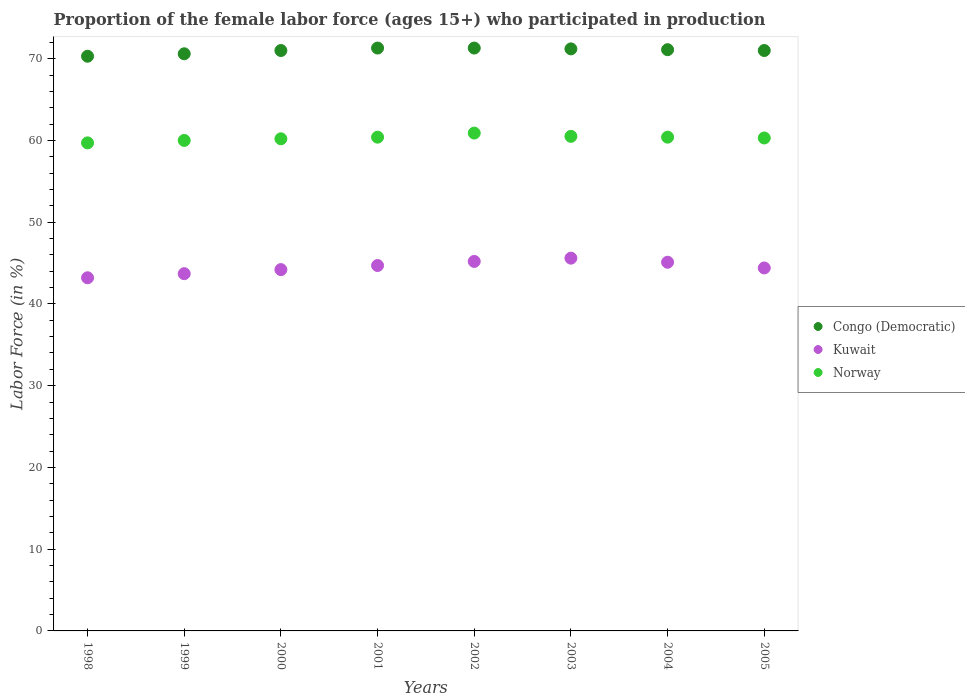Is the number of dotlines equal to the number of legend labels?
Offer a very short reply. Yes. What is the proportion of the female labor force who participated in production in Norway in 1998?
Ensure brevity in your answer.  59.7. Across all years, what is the maximum proportion of the female labor force who participated in production in Congo (Democratic)?
Offer a very short reply. 71.3. Across all years, what is the minimum proportion of the female labor force who participated in production in Norway?
Give a very brief answer. 59.7. In which year was the proportion of the female labor force who participated in production in Norway maximum?
Give a very brief answer. 2002. What is the total proportion of the female labor force who participated in production in Kuwait in the graph?
Your response must be concise. 356.1. What is the difference between the proportion of the female labor force who participated in production in Congo (Democratic) in 2001 and that in 2003?
Provide a short and direct response. 0.1. What is the difference between the proportion of the female labor force who participated in production in Norway in 1999 and the proportion of the female labor force who participated in production in Kuwait in 2000?
Offer a terse response. 15.8. What is the average proportion of the female labor force who participated in production in Congo (Democratic) per year?
Your answer should be very brief. 70.98. In the year 2001, what is the difference between the proportion of the female labor force who participated in production in Congo (Democratic) and proportion of the female labor force who participated in production in Kuwait?
Make the answer very short. 26.6. In how many years, is the proportion of the female labor force who participated in production in Congo (Democratic) greater than 44 %?
Offer a terse response. 8. What is the ratio of the proportion of the female labor force who participated in production in Congo (Democratic) in 2000 to that in 2001?
Your answer should be very brief. 1. What is the difference between the highest and the lowest proportion of the female labor force who participated in production in Kuwait?
Provide a short and direct response. 2.4. In how many years, is the proportion of the female labor force who participated in production in Norway greater than the average proportion of the female labor force who participated in production in Norway taken over all years?
Offer a terse response. 4. Is it the case that in every year, the sum of the proportion of the female labor force who participated in production in Congo (Democratic) and proportion of the female labor force who participated in production in Norway  is greater than the proportion of the female labor force who participated in production in Kuwait?
Offer a very short reply. Yes. Is the proportion of the female labor force who participated in production in Congo (Democratic) strictly greater than the proportion of the female labor force who participated in production in Kuwait over the years?
Offer a terse response. Yes. Is the proportion of the female labor force who participated in production in Kuwait strictly less than the proportion of the female labor force who participated in production in Norway over the years?
Your answer should be compact. Yes. How many dotlines are there?
Make the answer very short. 3. How many years are there in the graph?
Keep it short and to the point. 8. What is the difference between two consecutive major ticks on the Y-axis?
Your answer should be very brief. 10. Does the graph contain grids?
Ensure brevity in your answer.  No. Where does the legend appear in the graph?
Offer a very short reply. Center right. How many legend labels are there?
Provide a succinct answer. 3. How are the legend labels stacked?
Your answer should be compact. Vertical. What is the title of the graph?
Provide a succinct answer. Proportion of the female labor force (ages 15+) who participated in production. What is the label or title of the Y-axis?
Your response must be concise. Labor Force (in %). What is the Labor Force (in %) of Congo (Democratic) in 1998?
Make the answer very short. 70.3. What is the Labor Force (in %) in Kuwait in 1998?
Make the answer very short. 43.2. What is the Labor Force (in %) of Norway in 1998?
Your answer should be very brief. 59.7. What is the Labor Force (in %) in Congo (Democratic) in 1999?
Offer a terse response. 70.6. What is the Labor Force (in %) in Kuwait in 1999?
Ensure brevity in your answer.  43.7. What is the Labor Force (in %) in Norway in 1999?
Provide a short and direct response. 60. What is the Labor Force (in %) in Congo (Democratic) in 2000?
Your answer should be very brief. 71. What is the Labor Force (in %) of Kuwait in 2000?
Offer a very short reply. 44.2. What is the Labor Force (in %) of Norway in 2000?
Provide a short and direct response. 60.2. What is the Labor Force (in %) in Congo (Democratic) in 2001?
Keep it short and to the point. 71.3. What is the Labor Force (in %) in Kuwait in 2001?
Your response must be concise. 44.7. What is the Labor Force (in %) of Norway in 2001?
Ensure brevity in your answer.  60.4. What is the Labor Force (in %) in Congo (Democratic) in 2002?
Offer a very short reply. 71.3. What is the Labor Force (in %) of Kuwait in 2002?
Give a very brief answer. 45.2. What is the Labor Force (in %) of Norway in 2002?
Make the answer very short. 60.9. What is the Labor Force (in %) in Congo (Democratic) in 2003?
Ensure brevity in your answer.  71.2. What is the Labor Force (in %) in Kuwait in 2003?
Your response must be concise. 45.6. What is the Labor Force (in %) of Norway in 2003?
Ensure brevity in your answer.  60.5. What is the Labor Force (in %) of Congo (Democratic) in 2004?
Provide a succinct answer. 71.1. What is the Labor Force (in %) in Kuwait in 2004?
Your response must be concise. 45.1. What is the Labor Force (in %) of Norway in 2004?
Keep it short and to the point. 60.4. What is the Labor Force (in %) in Congo (Democratic) in 2005?
Provide a succinct answer. 71. What is the Labor Force (in %) in Kuwait in 2005?
Keep it short and to the point. 44.4. What is the Labor Force (in %) in Norway in 2005?
Ensure brevity in your answer.  60.3. Across all years, what is the maximum Labor Force (in %) of Congo (Democratic)?
Your answer should be very brief. 71.3. Across all years, what is the maximum Labor Force (in %) of Kuwait?
Offer a terse response. 45.6. Across all years, what is the maximum Labor Force (in %) of Norway?
Give a very brief answer. 60.9. Across all years, what is the minimum Labor Force (in %) of Congo (Democratic)?
Your response must be concise. 70.3. Across all years, what is the minimum Labor Force (in %) in Kuwait?
Provide a succinct answer. 43.2. Across all years, what is the minimum Labor Force (in %) in Norway?
Give a very brief answer. 59.7. What is the total Labor Force (in %) of Congo (Democratic) in the graph?
Ensure brevity in your answer.  567.8. What is the total Labor Force (in %) in Kuwait in the graph?
Keep it short and to the point. 356.1. What is the total Labor Force (in %) of Norway in the graph?
Provide a short and direct response. 482.4. What is the difference between the Labor Force (in %) of Congo (Democratic) in 1998 and that in 1999?
Provide a short and direct response. -0.3. What is the difference between the Labor Force (in %) of Kuwait in 1998 and that in 1999?
Your answer should be compact. -0.5. What is the difference between the Labor Force (in %) of Congo (Democratic) in 1998 and that in 2000?
Provide a succinct answer. -0.7. What is the difference between the Labor Force (in %) in Kuwait in 1998 and that in 2001?
Keep it short and to the point. -1.5. What is the difference between the Labor Force (in %) of Norway in 1998 and that in 2001?
Your answer should be compact. -0.7. What is the difference between the Labor Force (in %) in Kuwait in 1998 and that in 2002?
Your answer should be compact. -2. What is the difference between the Labor Force (in %) of Kuwait in 1998 and that in 2003?
Your response must be concise. -2.4. What is the difference between the Labor Force (in %) of Congo (Democratic) in 1998 and that in 2004?
Provide a succinct answer. -0.8. What is the difference between the Labor Force (in %) in Kuwait in 1998 and that in 2004?
Provide a succinct answer. -1.9. What is the difference between the Labor Force (in %) in Kuwait in 1999 and that in 2000?
Make the answer very short. -0.5. What is the difference between the Labor Force (in %) in Norway in 1999 and that in 2000?
Offer a very short reply. -0.2. What is the difference between the Labor Force (in %) of Norway in 1999 and that in 2001?
Your answer should be very brief. -0.4. What is the difference between the Labor Force (in %) of Kuwait in 1999 and that in 2002?
Ensure brevity in your answer.  -1.5. What is the difference between the Labor Force (in %) in Norway in 1999 and that in 2002?
Give a very brief answer. -0.9. What is the difference between the Labor Force (in %) in Kuwait in 1999 and that in 2003?
Offer a terse response. -1.9. What is the difference between the Labor Force (in %) in Congo (Democratic) in 1999 and that in 2004?
Make the answer very short. -0.5. What is the difference between the Labor Force (in %) in Kuwait in 1999 and that in 2004?
Keep it short and to the point. -1.4. What is the difference between the Labor Force (in %) in Norway in 1999 and that in 2004?
Ensure brevity in your answer.  -0.4. What is the difference between the Labor Force (in %) in Congo (Democratic) in 1999 and that in 2005?
Your answer should be very brief. -0.4. What is the difference between the Labor Force (in %) of Kuwait in 1999 and that in 2005?
Provide a succinct answer. -0.7. What is the difference between the Labor Force (in %) of Congo (Democratic) in 2000 and that in 2001?
Your answer should be very brief. -0.3. What is the difference between the Labor Force (in %) of Kuwait in 2000 and that in 2002?
Your response must be concise. -1. What is the difference between the Labor Force (in %) in Congo (Democratic) in 2000 and that in 2004?
Your answer should be very brief. -0.1. What is the difference between the Labor Force (in %) of Kuwait in 2000 and that in 2004?
Keep it short and to the point. -0.9. What is the difference between the Labor Force (in %) of Norway in 2001 and that in 2002?
Make the answer very short. -0.5. What is the difference between the Labor Force (in %) of Congo (Democratic) in 2001 and that in 2004?
Provide a succinct answer. 0.2. What is the difference between the Labor Force (in %) in Norway in 2001 and that in 2004?
Your answer should be compact. 0. What is the difference between the Labor Force (in %) of Congo (Democratic) in 2001 and that in 2005?
Offer a very short reply. 0.3. What is the difference between the Labor Force (in %) in Kuwait in 2001 and that in 2005?
Give a very brief answer. 0.3. What is the difference between the Labor Force (in %) of Congo (Democratic) in 2002 and that in 2003?
Your answer should be compact. 0.1. What is the difference between the Labor Force (in %) in Congo (Democratic) in 2002 and that in 2004?
Offer a very short reply. 0.2. What is the difference between the Labor Force (in %) of Norway in 2002 and that in 2004?
Keep it short and to the point. 0.5. What is the difference between the Labor Force (in %) in Congo (Democratic) in 2002 and that in 2005?
Give a very brief answer. 0.3. What is the difference between the Labor Force (in %) of Congo (Democratic) in 2003 and that in 2004?
Ensure brevity in your answer.  0.1. What is the difference between the Labor Force (in %) in Norway in 2003 and that in 2004?
Your answer should be compact. 0.1. What is the difference between the Labor Force (in %) in Congo (Democratic) in 2003 and that in 2005?
Make the answer very short. 0.2. What is the difference between the Labor Force (in %) of Norway in 2003 and that in 2005?
Provide a short and direct response. 0.2. What is the difference between the Labor Force (in %) in Kuwait in 2004 and that in 2005?
Provide a short and direct response. 0.7. What is the difference between the Labor Force (in %) in Congo (Democratic) in 1998 and the Labor Force (in %) in Kuwait in 1999?
Keep it short and to the point. 26.6. What is the difference between the Labor Force (in %) of Kuwait in 1998 and the Labor Force (in %) of Norway in 1999?
Offer a very short reply. -16.8. What is the difference between the Labor Force (in %) in Congo (Democratic) in 1998 and the Labor Force (in %) in Kuwait in 2000?
Provide a short and direct response. 26.1. What is the difference between the Labor Force (in %) in Congo (Democratic) in 1998 and the Labor Force (in %) in Kuwait in 2001?
Ensure brevity in your answer.  25.6. What is the difference between the Labor Force (in %) of Congo (Democratic) in 1998 and the Labor Force (in %) of Norway in 2001?
Your response must be concise. 9.9. What is the difference between the Labor Force (in %) of Kuwait in 1998 and the Labor Force (in %) of Norway in 2001?
Ensure brevity in your answer.  -17.2. What is the difference between the Labor Force (in %) in Congo (Democratic) in 1998 and the Labor Force (in %) in Kuwait in 2002?
Offer a terse response. 25.1. What is the difference between the Labor Force (in %) of Congo (Democratic) in 1998 and the Labor Force (in %) of Norway in 2002?
Provide a short and direct response. 9.4. What is the difference between the Labor Force (in %) of Kuwait in 1998 and the Labor Force (in %) of Norway in 2002?
Keep it short and to the point. -17.7. What is the difference between the Labor Force (in %) in Congo (Democratic) in 1998 and the Labor Force (in %) in Kuwait in 2003?
Keep it short and to the point. 24.7. What is the difference between the Labor Force (in %) of Kuwait in 1998 and the Labor Force (in %) of Norway in 2003?
Keep it short and to the point. -17.3. What is the difference between the Labor Force (in %) of Congo (Democratic) in 1998 and the Labor Force (in %) of Kuwait in 2004?
Offer a very short reply. 25.2. What is the difference between the Labor Force (in %) of Congo (Democratic) in 1998 and the Labor Force (in %) of Norway in 2004?
Ensure brevity in your answer.  9.9. What is the difference between the Labor Force (in %) of Kuwait in 1998 and the Labor Force (in %) of Norway in 2004?
Keep it short and to the point. -17.2. What is the difference between the Labor Force (in %) in Congo (Democratic) in 1998 and the Labor Force (in %) in Kuwait in 2005?
Provide a short and direct response. 25.9. What is the difference between the Labor Force (in %) of Congo (Democratic) in 1998 and the Labor Force (in %) of Norway in 2005?
Offer a very short reply. 10. What is the difference between the Labor Force (in %) of Kuwait in 1998 and the Labor Force (in %) of Norway in 2005?
Provide a short and direct response. -17.1. What is the difference between the Labor Force (in %) in Congo (Democratic) in 1999 and the Labor Force (in %) in Kuwait in 2000?
Your answer should be very brief. 26.4. What is the difference between the Labor Force (in %) of Kuwait in 1999 and the Labor Force (in %) of Norway in 2000?
Provide a succinct answer. -16.5. What is the difference between the Labor Force (in %) of Congo (Democratic) in 1999 and the Labor Force (in %) of Kuwait in 2001?
Your response must be concise. 25.9. What is the difference between the Labor Force (in %) of Congo (Democratic) in 1999 and the Labor Force (in %) of Norway in 2001?
Offer a very short reply. 10.2. What is the difference between the Labor Force (in %) of Kuwait in 1999 and the Labor Force (in %) of Norway in 2001?
Your answer should be compact. -16.7. What is the difference between the Labor Force (in %) in Congo (Democratic) in 1999 and the Labor Force (in %) in Kuwait in 2002?
Your answer should be very brief. 25.4. What is the difference between the Labor Force (in %) in Congo (Democratic) in 1999 and the Labor Force (in %) in Norway in 2002?
Give a very brief answer. 9.7. What is the difference between the Labor Force (in %) of Kuwait in 1999 and the Labor Force (in %) of Norway in 2002?
Offer a very short reply. -17.2. What is the difference between the Labor Force (in %) of Congo (Democratic) in 1999 and the Labor Force (in %) of Kuwait in 2003?
Your answer should be very brief. 25. What is the difference between the Labor Force (in %) in Kuwait in 1999 and the Labor Force (in %) in Norway in 2003?
Keep it short and to the point. -16.8. What is the difference between the Labor Force (in %) in Congo (Democratic) in 1999 and the Labor Force (in %) in Kuwait in 2004?
Offer a terse response. 25.5. What is the difference between the Labor Force (in %) in Kuwait in 1999 and the Labor Force (in %) in Norway in 2004?
Offer a terse response. -16.7. What is the difference between the Labor Force (in %) of Congo (Democratic) in 1999 and the Labor Force (in %) of Kuwait in 2005?
Your answer should be compact. 26.2. What is the difference between the Labor Force (in %) in Congo (Democratic) in 1999 and the Labor Force (in %) in Norway in 2005?
Make the answer very short. 10.3. What is the difference between the Labor Force (in %) in Kuwait in 1999 and the Labor Force (in %) in Norway in 2005?
Your answer should be compact. -16.6. What is the difference between the Labor Force (in %) in Congo (Democratic) in 2000 and the Labor Force (in %) in Kuwait in 2001?
Your answer should be compact. 26.3. What is the difference between the Labor Force (in %) of Kuwait in 2000 and the Labor Force (in %) of Norway in 2001?
Provide a short and direct response. -16.2. What is the difference between the Labor Force (in %) in Congo (Democratic) in 2000 and the Labor Force (in %) in Kuwait in 2002?
Offer a very short reply. 25.8. What is the difference between the Labor Force (in %) of Congo (Democratic) in 2000 and the Labor Force (in %) of Norway in 2002?
Your response must be concise. 10.1. What is the difference between the Labor Force (in %) in Kuwait in 2000 and the Labor Force (in %) in Norway in 2002?
Your answer should be compact. -16.7. What is the difference between the Labor Force (in %) of Congo (Democratic) in 2000 and the Labor Force (in %) of Kuwait in 2003?
Give a very brief answer. 25.4. What is the difference between the Labor Force (in %) in Congo (Democratic) in 2000 and the Labor Force (in %) in Norway in 2003?
Give a very brief answer. 10.5. What is the difference between the Labor Force (in %) of Kuwait in 2000 and the Labor Force (in %) of Norway in 2003?
Offer a very short reply. -16.3. What is the difference between the Labor Force (in %) in Congo (Democratic) in 2000 and the Labor Force (in %) in Kuwait in 2004?
Provide a short and direct response. 25.9. What is the difference between the Labor Force (in %) in Kuwait in 2000 and the Labor Force (in %) in Norway in 2004?
Give a very brief answer. -16.2. What is the difference between the Labor Force (in %) of Congo (Democratic) in 2000 and the Labor Force (in %) of Kuwait in 2005?
Your answer should be very brief. 26.6. What is the difference between the Labor Force (in %) of Congo (Democratic) in 2000 and the Labor Force (in %) of Norway in 2005?
Your answer should be very brief. 10.7. What is the difference between the Labor Force (in %) in Kuwait in 2000 and the Labor Force (in %) in Norway in 2005?
Make the answer very short. -16.1. What is the difference between the Labor Force (in %) in Congo (Democratic) in 2001 and the Labor Force (in %) in Kuwait in 2002?
Give a very brief answer. 26.1. What is the difference between the Labor Force (in %) of Congo (Democratic) in 2001 and the Labor Force (in %) of Norway in 2002?
Keep it short and to the point. 10.4. What is the difference between the Labor Force (in %) in Kuwait in 2001 and the Labor Force (in %) in Norway in 2002?
Keep it short and to the point. -16.2. What is the difference between the Labor Force (in %) of Congo (Democratic) in 2001 and the Labor Force (in %) of Kuwait in 2003?
Offer a terse response. 25.7. What is the difference between the Labor Force (in %) of Kuwait in 2001 and the Labor Force (in %) of Norway in 2003?
Give a very brief answer. -15.8. What is the difference between the Labor Force (in %) in Congo (Democratic) in 2001 and the Labor Force (in %) in Kuwait in 2004?
Offer a terse response. 26.2. What is the difference between the Labor Force (in %) in Congo (Democratic) in 2001 and the Labor Force (in %) in Norway in 2004?
Offer a terse response. 10.9. What is the difference between the Labor Force (in %) in Kuwait in 2001 and the Labor Force (in %) in Norway in 2004?
Provide a short and direct response. -15.7. What is the difference between the Labor Force (in %) of Congo (Democratic) in 2001 and the Labor Force (in %) of Kuwait in 2005?
Provide a succinct answer. 26.9. What is the difference between the Labor Force (in %) in Congo (Democratic) in 2001 and the Labor Force (in %) in Norway in 2005?
Make the answer very short. 11. What is the difference between the Labor Force (in %) of Kuwait in 2001 and the Labor Force (in %) of Norway in 2005?
Provide a short and direct response. -15.6. What is the difference between the Labor Force (in %) in Congo (Democratic) in 2002 and the Labor Force (in %) in Kuwait in 2003?
Keep it short and to the point. 25.7. What is the difference between the Labor Force (in %) in Congo (Democratic) in 2002 and the Labor Force (in %) in Norway in 2003?
Your answer should be compact. 10.8. What is the difference between the Labor Force (in %) of Kuwait in 2002 and the Labor Force (in %) of Norway in 2003?
Offer a very short reply. -15.3. What is the difference between the Labor Force (in %) of Congo (Democratic) in 2002 and the Labor Force (in %) of Kuwait in 2004?
Give a very brief answer. 26.2. What is the difference between the Labor Force (in %) in Kuwait in 2002 and the Labor Force (in %) in Norway in 2004?
Your answer should be compact. -15.2. What is the difference between the Labor Force (in %) in Congo (Democratic) in 2002 and the Labor Force (in %) in Kuwait in 2005?
Give a very brief answer. 26.9. What is the difference between the Labor Force (in %) of Congo (Democratic) in 2002 and the Labor Force (in %) of Norway in 2005?
Your response must be concise. 11. What is the difference between the Labor Force (in %) in Kuwait in 2002 and the Labor Force (in %) in Norway in 2005?
Give a very brief answer. -15.1. What is the difference between the Labor Force (in %) of Congo (Democratic) in 2003 and the Labor Force (in %) of Kuwait in 2004?
Ensure brevity in your answer.  26.1. What is the difference between the Labor Force (in %) of Congo (Democratic) in 2003 and the Labor Force (in %) of Norway in 2004?
Your response must be concise. 10.8. What is the difference between the Labor Force (in %) of Kuwait in 2003 and the Labor Force (in %) of Norway in 2004?
Ensure brevity in your answer.  -14.8. What is the difference between the Labor Force (in %) in Congo (Democratic) in 2003 and the Labor Force (in %) in Kuwait in 2005?
Give a very brief answer. 26.8. What is the difference between the Labor Force (in %) of Kuwait in 2003 and the Labor Force (in %) of Norway in 2005?
Your answer should be very brief. -14.7. What is the difference between the Labor Force (in %) of Congo (Democratic) in 2004 and the Labor Force (in %) of Kuwait in 2005?
Make the answer very short. 26.7. What is the difference between the Labor Force (in %) in Congo (Democratic) in 2004 and the Labor Force (in %) in Norway in 2005?
Your answer should be compact. 10.8. What is the difference between the Labor Force (in %) of Kuwait in 2004 and the Labor Force (in %) of Norway in 2005?
Your answer should be compact. -15.2. What is the average Labor Force (in %) of Congo (Democratic) per year?
Keep it short and to the point. 70.97. What is the average Labor Force (in %) in Kuwait per year?
Provide a short and direct response. 44.51. What is the average Labor Force (in %) in Norway per year?
Your response must be concise. 60.3. In the year 1998, what is the difference between the Labor Force (in %) in Congo (Democratic) and Labor Force (in %) in Kuwait?
Make the answer very short. 27.1. In the year 1998, what is the difference between the Labor Force (in %) in Kuwait and Labor Force (in %) in Norway?
Make the answer very short. -16.5. In the year 1999, what is the difference between the Labor Force (in %) of Congo (Democratic) and Labor Force (in %) of Kuwait?
Ensure brevity in your answer.  26.9. In the year 1999, what is the difference between the Labor Force (in %) of Congo (Democratic) and Labor Force (in %) of Norway?
Offer a terse response. 10.6. In the year 1999, what is the difference between the Labor Force (in %) of Kuwait and Labor Force (in %) of Norway?
Give a very brief answer. -16.3. In the year 2000, what is the difference between the Labor Force (in %) in Congo (Democratic) and Labor Force (in %) in Kuwait?
Provide a succinct answer. 26.8. In the year 2001, what is the difference between the Labor Force (in %) of Congo (Democratic) and Labor Force (in %) of Kuwait?
Provide a succinct answer. 26.6. In the year 2001, what is the difference between the Labor Force (in %) in Congo (Democratic) and Labor Force (in %) in Norway?
Your answer should be compact. 10.9. In the year 2001, what is the difference between the Labor Force (in %) of Kuwait and Labor Force (in %) of Norway?
Your answer should be very brief. -15.7. In the year 2002, what is the difference between the Labor Force (in %) of Congo (Democratic) and Labor Force (in %) of Kuwait?
Your answer should be compact. 26.1. In the year 2002, what is the difference between the Labor Force (in %) in Congo (Democratic) and Labor Force (in %) in Norway?
Provide a short and direct response. 10.4. In the year 2002, what is the difference between the Labor Force (in %) of Kuwait and Labor Force (in %) of Norway?
Give a very brief answer. -15.7. In the year 2003, what is the difference between the Labor Force (in %) in Congo (Democratic) and Labor Force (in %) in Kuwait?
Offer a terse response. 25.6. In the year 2003, what is the difference between the Labor Force (in %) of Congo (Democratic) and Labor Force (in %) of Norway?
Your answer should be compact. 10.7. In the year 2003, what is the difference between the Labor Force (in %) of Kuwait and Labor Force (in %) of Norway?
Provide a short and direct response. -14.9. In the year 2004, what is the difference between the Labor Force (in %) of Congo (Democratic) and Labor Force (in %) of Norway?
Offer a very short reply. 10.7. In the year 2004, what is the difference between the Labor Force (in %) in Kuwait and Labor Force (in %) in Norway?
Provide a short and direct response. -15.3. In the year 2005, what is the difference between the Labor Force (in %) in Congo (Democratic) and Labor Force (in %) in Kuwait?
Your answer should be very brief. 26.6. In the year 2005, what is the difference between the Labor Force (in %) of Congo (Democratic) and Labor Force (in %) of Norway?
Keep it short and to the point. 10.7. In the year 2005, what is the difference between the Labor Force (in %) of Kuwait and Labor Force (in %) of Norway?
Make the answer very short. -15.9. What is the ratio of the Labor Force (in %) of Kuwait in 1998 to that in 2000?
Give a very brief answer. 0.98. What is the ratio of the Labor Force (in %) in Congo (Democratic) in 1998 to that in 2001?
Your answer should be very brief. 0.99. What is the ratio of the Labor Force (in %) of Kuwait in 1998 to that in 2001?
Your response must be concise. 0.97. What is the ratio of the Labor Force (in %) in Norway in 1998 to that in 2001?
Your response must be concise. 0.99. What is the ratio of the Labor Force (in %) in Congo (Democratic) in 1998 to that in 2002?
Ensure brevity in your answer.  0.99. What is the ratio of the Labor Force (in %) in Kuwait in 1998 to that in 2002?
Ensure brevity in your answer.  0.96. What is the ratio of the Labor Force (in %) of Norway in 1998 to that in 2002?
Your answer should be compact. 0.98. What is the ratio of the Labor Force (in %) of Congo (Democratic) in 1998 to that in 2003?
Your response must be concise. 0.99. What is the ratio of the Labor Force (in %) in Congo (Democratic) in 1998 to that in 2004?
Give a very brief answer. 0.99. What is the ratio of the Labor Force (in %) in Kuwait in 1998 to that in 2004?
Make the answer very short. 0.96. What is the ratio of the Labor Force (in %) in Norway in 1998 to that in 2004?
Give a very brief answer. 0.99. What is the ratio of the Labor Force (in %) of Kuwait in 1999 to that in 2000?
Keep it short and to the point. 0.99. What is the ratio of the Labor Force (in %) in Norway in 1999 to that in 2000?
Ensure brevity in your answer.  1. What is the ratio of the Labor Force (in %) of Congo (Democratic) in 1999 to that in 2001?
Provide a short and direct response. 0.99. What is the ratio of the Labor Force (in %) in Kuwait in 1999 to that in 2001?
Keep it short and to the point. 0.98. What is the ratio of the Labor Force (in %) in Norway in 1999 to that in 2001?
Your response must be concise. 0.99. What is the ratio of the Labor Force (in %) of Congo (Democratic) in 1999 to that in 2002?
Offer a very short reply. 0.99. What is the ratio of the Labor Force (in %) in Kuwait in 1999 to that in 2002?
Your answer should be very brief. 0.97. What is the ratio of the Labor Force (in %) in Norway in 1999 to that in 2002?
Make the answer very short. 0.99. What is the ratio of the Labor Force (in %) in Congo (Democratic) in 1999 to that in 2003?
Make the answer very short. 0.99. What is the ratio of the Labor Force (in %) of Norway in 1999 to that in 2003?
Your answer should be very brief. 0.99. What is the ratio of the Labor Force (in %) of Kuwait in 1999 to that in 2004?
Your answer should be compact. 0.97. What is the ratio of the Labor Force (in %) of Kuwait in 1999 to that in 2005?
Provide a succinct answer. 0.98. What is the ratio of the Labor Force (in %) of Congo (Democratic) in 2000 to that in 2001?
Offer a terse response. 1. What is the ratio of the Labor Force (in %) in Kuwait in 2000 to that in 2001?
Your answer should be compact. 0.99. What is the ratio of the Labor Force (in %) in Norway in 2000 to that in 2001?
Provide a short and direct response. 1. What is the ratio of the Labor Force (in %) of Kuwait in 2000 to that in 2002?
Keep it short and to the point. 0.98. What is the ratio of the Labor Force (in %) in Kuwait in 2000 to that in 2003?
Offer a terse response. 0.97. What is the ratio of the Labor Force (in %) in Congo (Democratic) in 2000 to that in 2004?
Keep it short and to the point. 1. What is the ratio of the Labor Force (in %) in Kuwait in 2000 to that in 2004?
Provide a short and direct response. 0.98. What is the ratio of the Labor Force (in %) of Norway in 2000 to that in 2004?
Offer a very short reply. 1. What is the ratio of the Labor Force (in %) in Congo (Democratic) in 2000 to that in 2005?
Give a very brief answer. 1. What is the ratio of the Labor Force (in %) of Congo (Democratic) in 2001 to that in 2002?
Provide a succinct answer. 1. What is the ratio of the Labor Force (in %) of Kuwait in 2001 to that in 2002?
Your response must be concise. 0.99. What is the ratio of the Labor Force (in %) in Kuwait in 2001 to that in 2003?
Your answer should be compact. 0.98. What is the ratio of the Labor Force (in %) of Congo (Democratic) in 2001 to that in 2005?
Your answer should be very brief. 1. What is the ratio of the Labor Force (in %) in Kuwait in 2001 to that in 2005?
Ensure brevity in your answer.  1.01. What is the ratio of the Labor Force (in %) in Norway in 2001 to that in 2005?
Make the answer very short. 1. What is the ratio of the Labor Force (in %) in Congo (Democratic) in 2002 to that in 2003?
Your response must be concise. 1. What is the ratio of the Labor Force (in %) of Kuwait in 2002 to that in 2003?
Offer a terse response. 0.99. What is the ratio of the Labor Force (in %) of Norway in 2002 to that in 2003?
Make the answer very short. 1.01. What is the ratio of the Labor Force (in %) of Congo (Democratic) in 2002 to that in 2004?
Offer a terse response. 1. What is the ratio of the Labor Force (in %) in Kuwait in 2002 to that in 2004?
Your response must be concise. 1. What is the ratio of the Labor Force (in %) in Norway in 2002 to that in 2004?
Offer a terse response. 1.01. What is the ratio of the Labor Force (in %) in Kuwait in 2003 to that in 2004?
Your response must be concise. 1.01. What is the ratio of the Labor Force (in %) of Norway in 2003 to that in 2004?
Your answer should be compact. 1. What is the ratio of the Labor Force (in %) of Norway in 2003 to that in 2005?
Your response must be concise. 1. What is the ratio of the Labor Force (in %) in Kuwait in 2004 to that in 2005?
Offer a terse response. 1.02. What is the difference between the highest and the second highest Labor Force (in %) in Norway?
Your answer should be very brief. 0.4. 